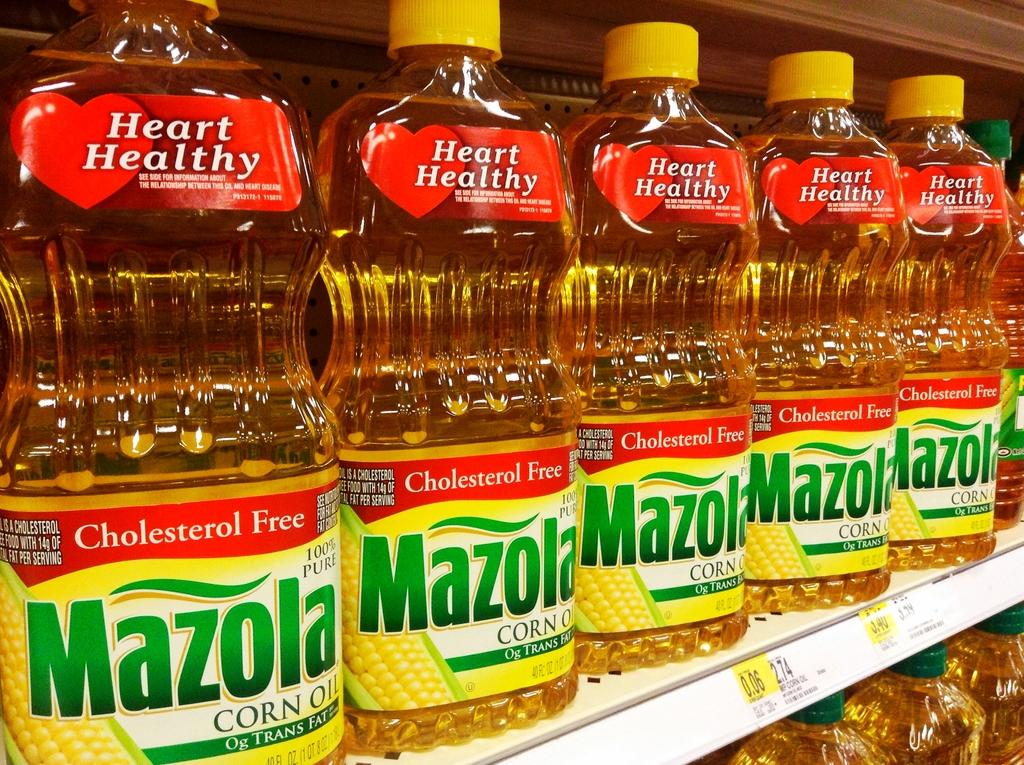Where was the image taken? The image was taken in a supermarket. What can be seen in the middle of the image? There are six bottles in the middle of the image. Are there any more bottles visible in the image? Yes, there are additional bottles at the bottom of the image. Can you see any flies buzzing around the bottles in the image? There is no mention of flies in the image, so we cannot determine if any are present. 